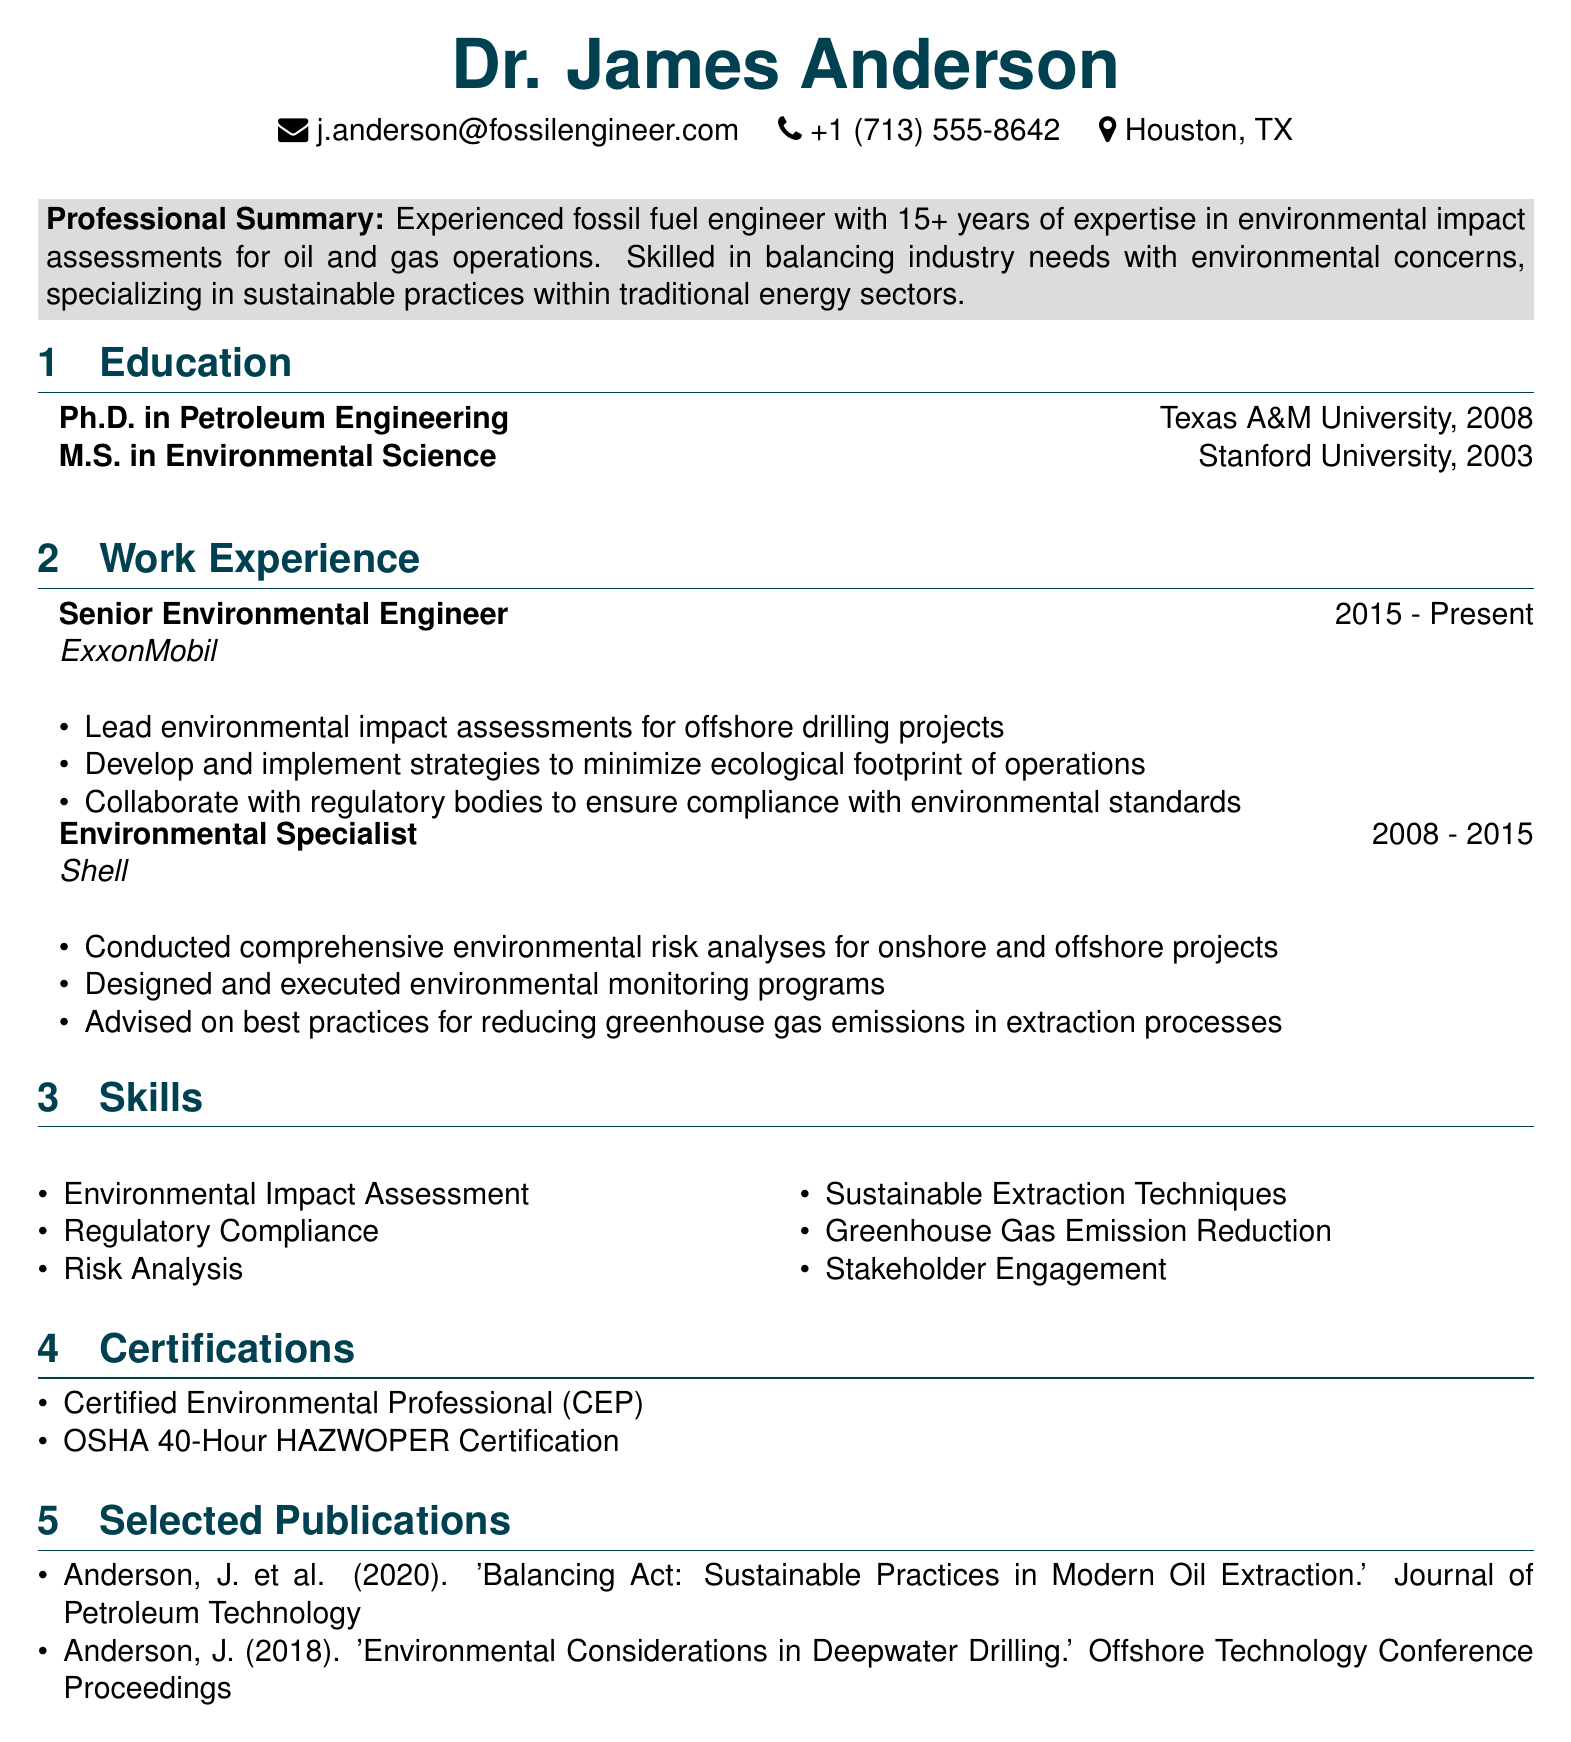What is Dr. James Anderson's highest degree? The document clearly states the highest degree earned by Dr. James Anderson is a Ph.D. in Petroleum Engineering.
Answer: Ph.D. in Petroleum Engineering Which company does Dr. James Anderson currently work for? The work experience section indicates that Dr. James Anderson is currently employed by ExxonMobil.
Answer: ExxonMobil How many years of experience does Dr. James Anderson have? The professional summary mentions that Dr. James Anderson has over 15 years of experience in his field.
Answer: 15+ years What does CEP stand for in the certifications section? The certifications include "Certified Environmental Professional," indicating what CEP stands for.
Answer: Certified Environmental Professional What are the main responsibilities of Dr. James Anderson at ExxonMobil? The responsibilities listed for his role include leading environmental impact assessments, strategy development for ecological footprint, and collaboration for compliance.
Answer: Lead environmental impact assessments for offshore drilling projects What was Dr. James Anderson's role before ExxonMobil? According to the work experience section, Dr. James Anderson worked as an Environmental Specialist before joining ExxonMobil.
Answer: Environmental Specialist In which publication did Dr. James Anderson write about sustainable practices in modern oil extraction? The selected publications list includes one that specifically addresses sustainable practices in oil extraction authored by Dr. Anderson.
Answer: 'Balancing Act: Sustainable Practices in Modern Oil Extraction' What year did Dr. James Anderson complete his master's degree? The education section states that Dr. James Anderson completed his M.S. in Environmental Science in 2003.
Answer: 2003 What type of analysis did Dr. James Anderson conduct at Shell? The responsibilities while working at Shell involved conducting comprehensive environmental risk analyses.
Answer: Comprehensive environmental risk analyses 